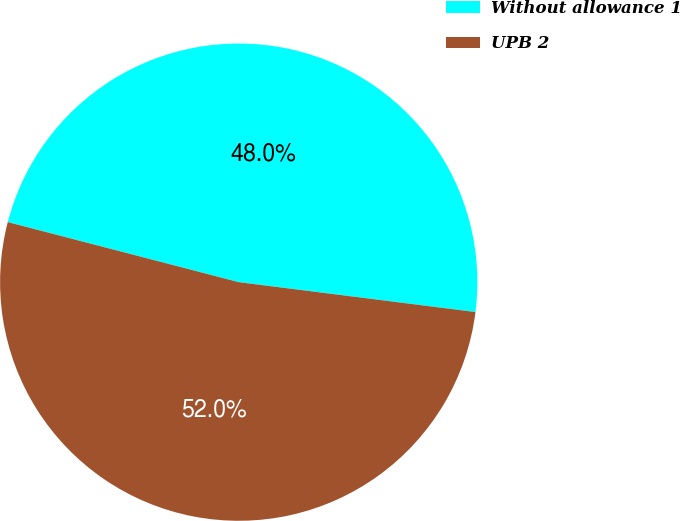Convert chart. <chart><loc_0><loc_0><loc_500><loc_500><pie_chart><fcel>Without allowance 1<fcel>UPB 2<nl><fcel>47.95%<fcel>52.05%<nl></chart> 